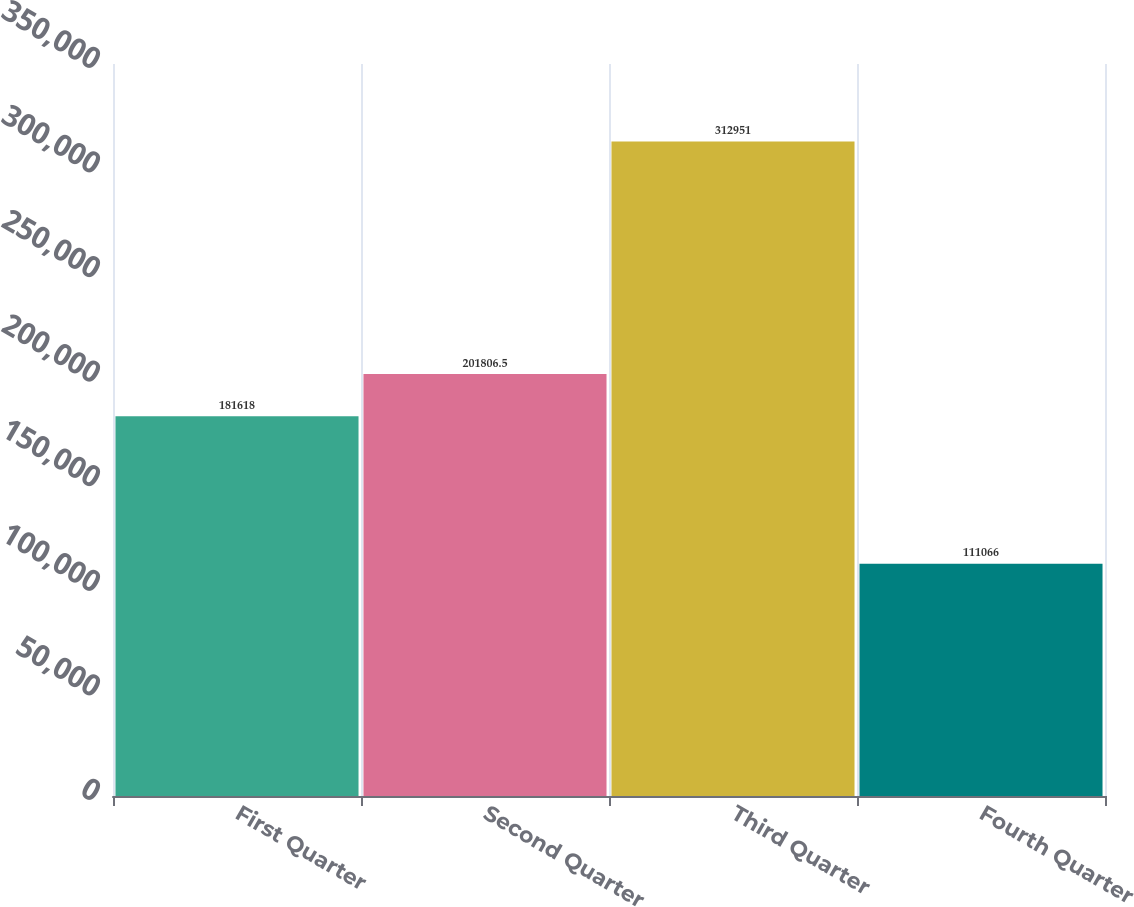Convert chart. <chart><loc_0><loc_0><loc_500><loc_500><bar_chart><fcel>First Quarter<fcel>Second Quarter<fcel>Third Quarter<fcel>Fourth Quarter<nl><fcel>181618<fcel>201806<fcel>312951<fcel>111066<nl></chart> 